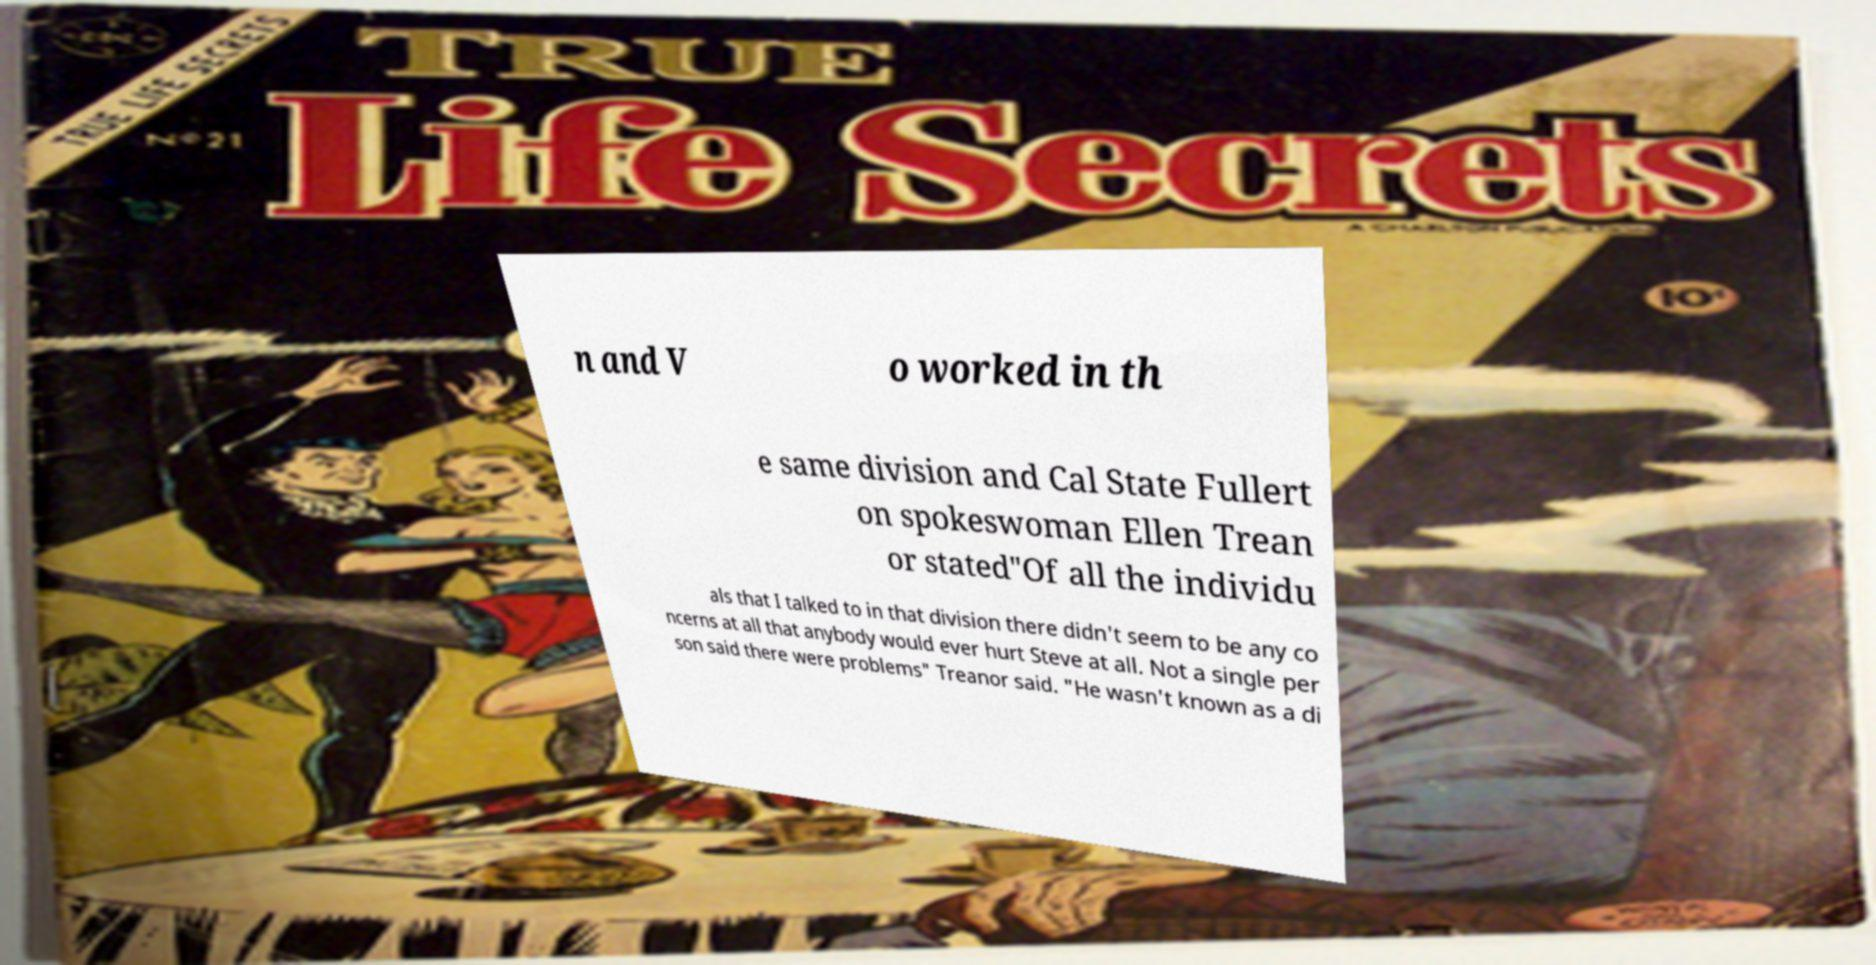Can you accurately transcribe the text from the provided image for me? n and V o worked in th e same division and Cal State Fullert on spokeswoman Ellen Trean or stated"Of all the individu als that I talked to in that division there didn't seem to be any co ncerns at all that anybody would ever hurt Steve at all. Not a single per son said there were problems" Treanor said. "He wasn't known as a di 